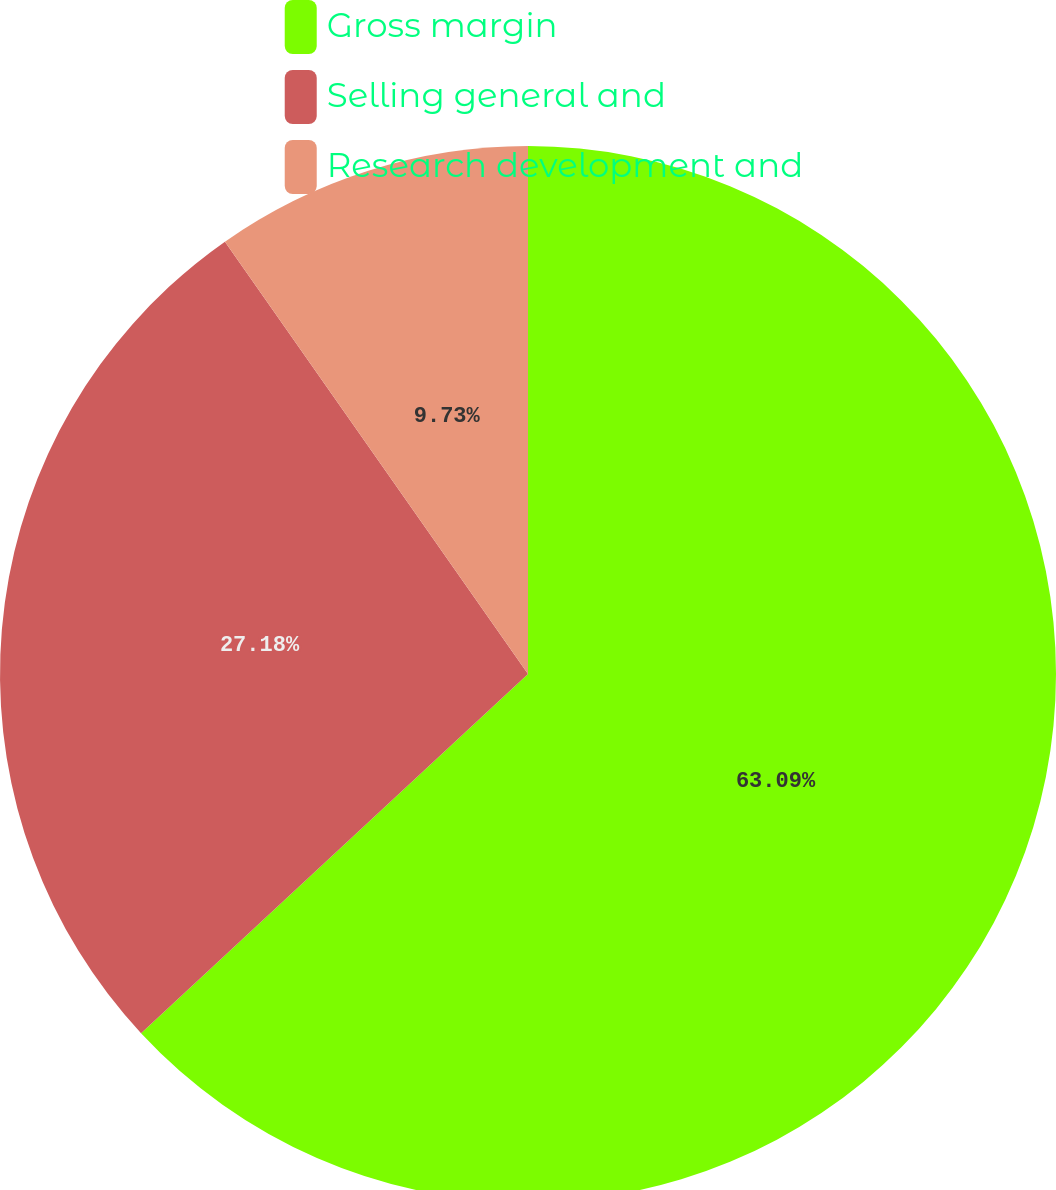Convert chart. <chart><loc_0><loc_0><loc_500><loc_500><pie_chart><fcel>Gross margin<fcel>Selling general and<fcel>Research development and<nl><fcel>63.09%<fcel>27.18%<fcel>9.73%<nl></chart> 